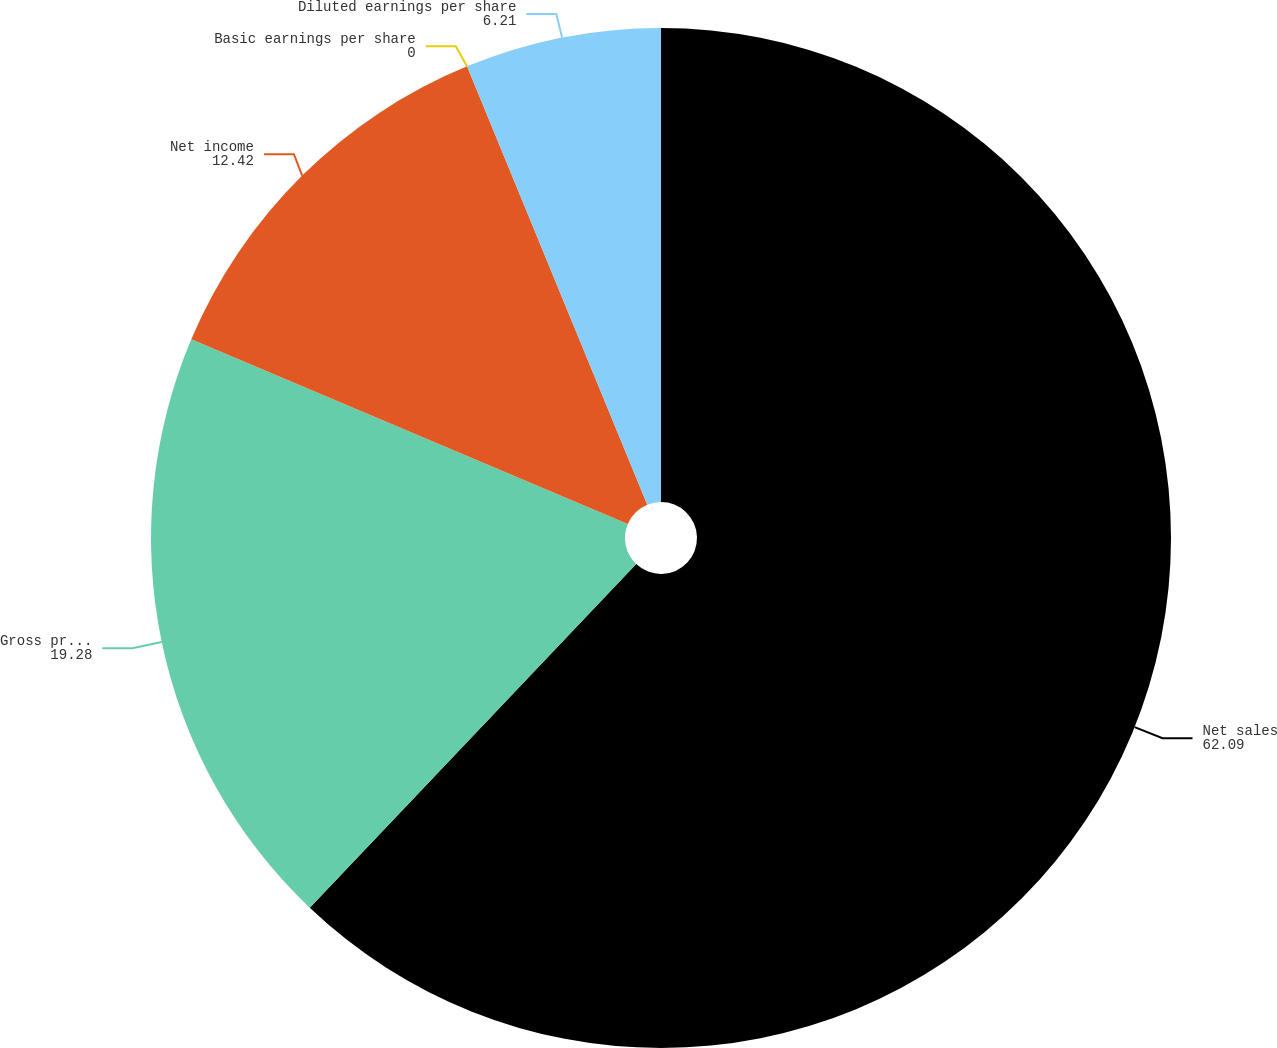Convert chart to OTSL. <chart><loc_0><loc_0><loc_500><loc_500><pie_chart><fcel>Net sales<fcel>Gross profit<fcel>Net income<fcel>Basic earnings per share<fcel>Diluted earnings per share<nl><fcel>62.09%<fcel>19.28%<fcel>12.42%<fcel>0.0%<fcel>6.21%<nl></chart> 